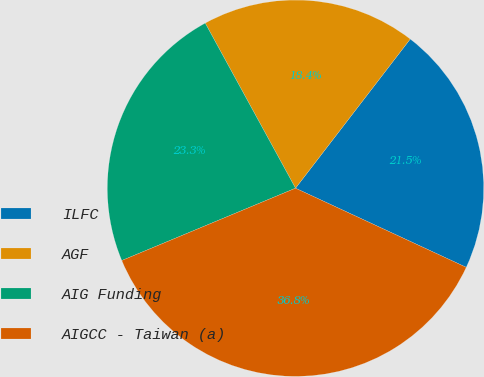Convert chart. <chart><loc_0><loc_0><loc_500><loc_500><pie_chart><fcel>ILFC<fcel>AGF<fcel>AIG Funding<fcel>AIGCC - Taiwan (a)<nl><fcel>21.47%<fcel>18.4%<fcel>23.31%<fcel>36.81%<nl></chart> 